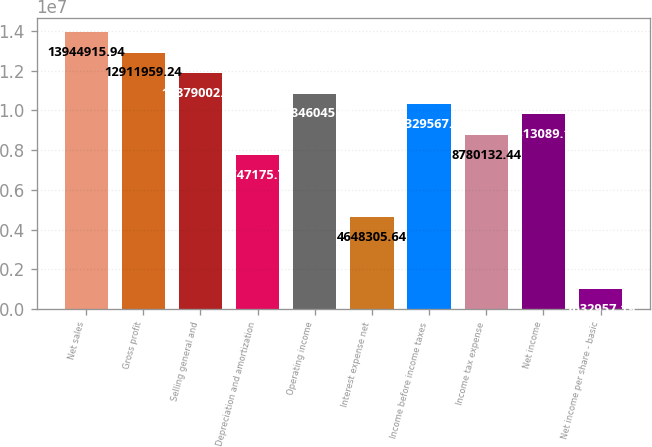Convert chart. <chart><loc_0><loc_0><loc_500><loc_500><bar_chart><fcel>Net sales<fcel>Gross profit<fcel>Selling general and<fcel>Depreciation and amortization<fcel>Operating income<fcel>Interest expense net<fcel>Income before income taxes<fcel>Income tax expense<fcel>Net income<fcel>Net income per share - basic<nl><fcel>1.39449e+07<fcel>1.2912e+07<fcel>1.1879e+07<fcel>7.74718e+06<fcel>1.0846e+07<fcel>4.64831e+06<fcel>1.03296e+07<fcel>8.78013e+06<fcel>9.81309e+06<fcel>1.03296e+06<nl></chart> 